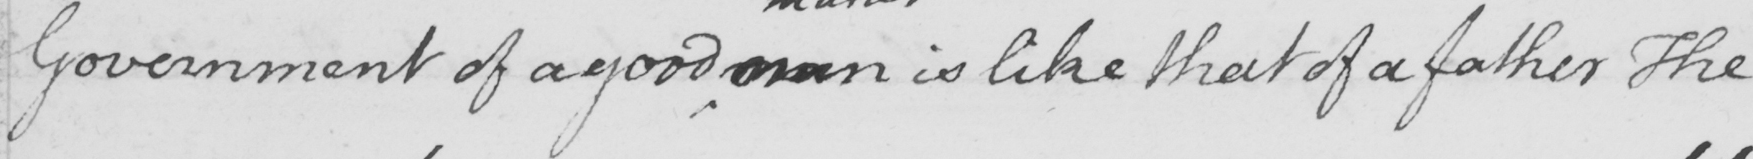What does this handwritten line say? Government of a good man is like that of a father The 